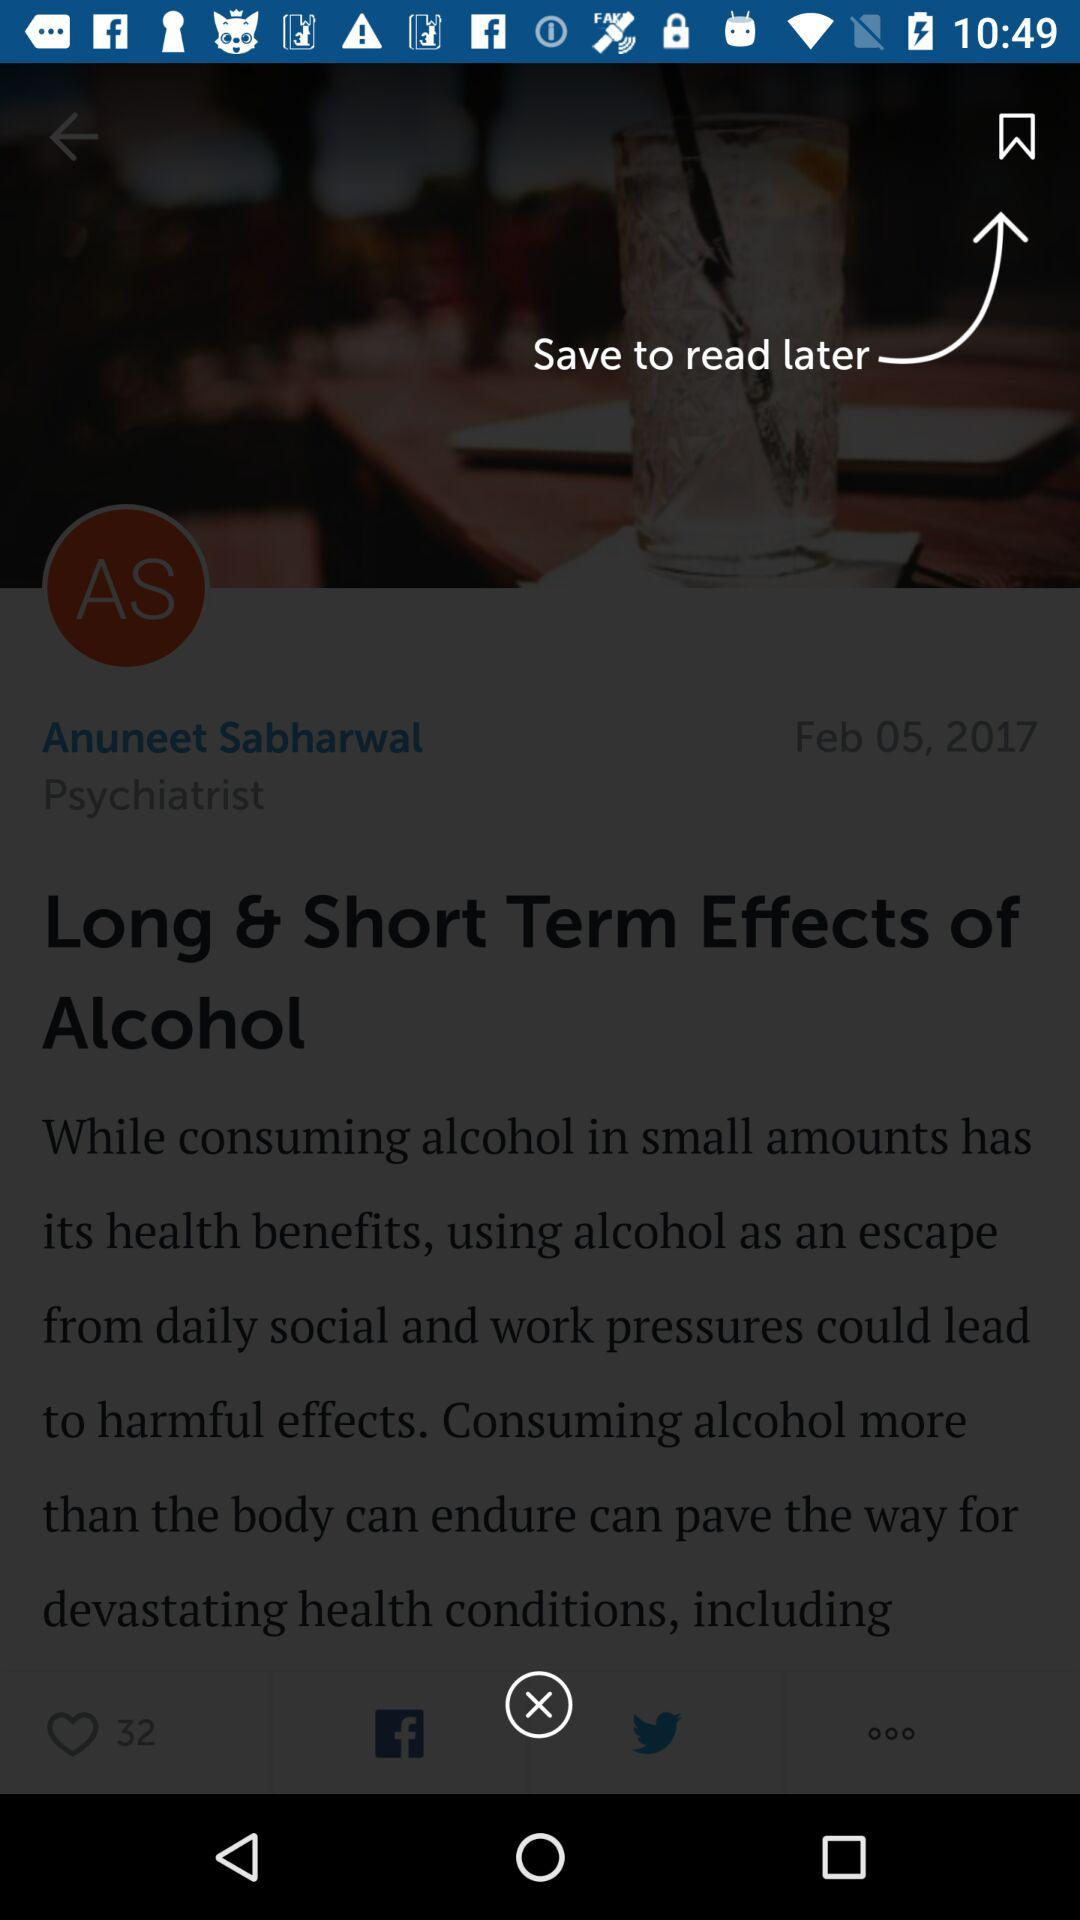What is the date? The date is February 5, 2017. 